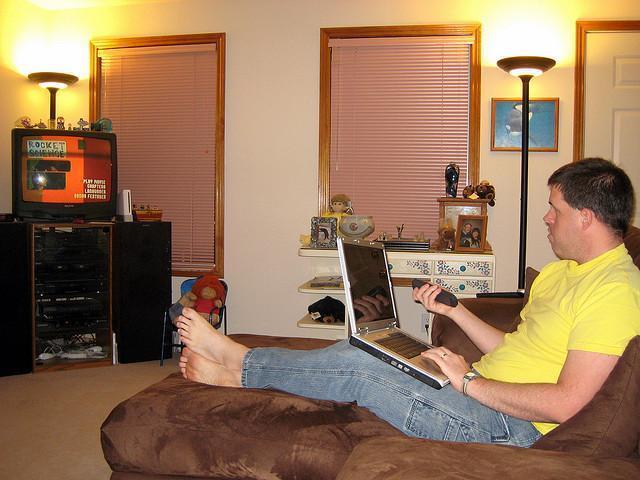How many laptops are there?
Give a very brief answer. 1. How many young elephants are shown?
Give a very brief answer. 0. 